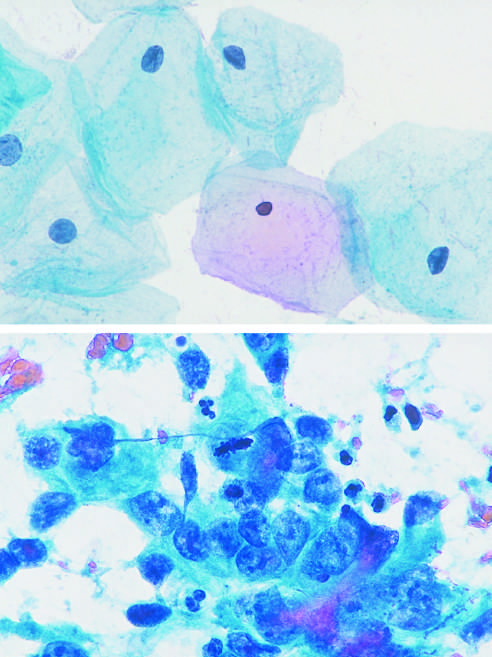s nuclear pleomorphism evident?
Answer the question using a single word or phrase. Yes 